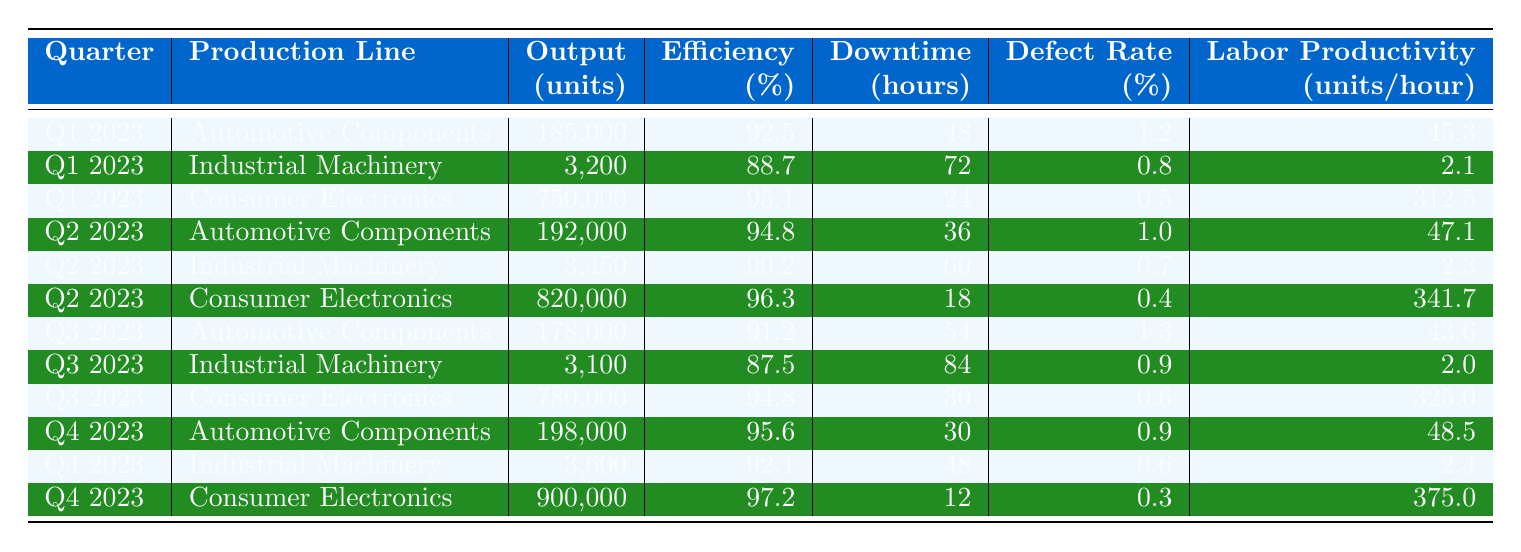What was the output of Consumer Electronics in Q4 2023? The output for Consumer Electronics in Q4 2023 is listed directly in the table as 900,000 units.
Answer: 900,000 What is the average efficiency for Automotive Components over the four quarters? The efficiencies for Automotive Components are 92.5, 94.8, 91.2, and 95.6. Adding these gives 374.1 and dividing by 4 yields 93.525.
Answer: 93.53 Was the defect rate for Industrial Machinery higher than for Consumer Electronics in Q1 2023? The defect rate for Industrial Machinery in Q1 2023 is 0.8%, and for Consumer Electronics, it is 0.5%. Since 0.8% is greater than 0.5%, the statement is true.
Answer: Yes Which production line had the highest labor productivity in Q2 2023? The labor productivity values for Q2 2023 are 47.1 for Automotive Components, 2.3 for Industrial Machinery, and 341.7 for Consumer Electronics. The highest value is 341.7, associated with Consumer Electronics.
Answer: Consumer Electronics What is the total output for Automotive Components across all quarters? The outputs for Automotive Components are 185,000 (Q1), 192,000 (Q2), 178,000 (Q3), and 198,000 (Q4). Adding these values gives a total output of 753,000 units.
Answer: 753,000 In which quarter did Industrial Machinery have the least downtime? The downtime for Industrial Machinery is recorded as 72 (Q1), 60 (Q2), 84 (Q3), and 48 (Q4). The least downtime is 48 hours in Q4.
Answer: Q4 2023 What percentage of efficiency was achieved by Consumer Electronics in Q3 2023? The efficiency for Consumer Electronics in Q3 2023 is explicitly indicated in the table as 94.8%.
Answer: 94.8% What is the difference in defect rates between Automotive Components and Consumer Electronics in Q2 2023? The defect rate for Automotive Components in Q2 2023 is 1.0%, and for Consumer Electronics, it is 0.4%. The difference is calculated as 1.0 - 0.4, which equals 0.6%.
Answer: 0.6% Which production line consistently maintained an efficiency above 90% throughout the four quarters? By reviewing the efficiency values for each quarter, Automotive Components (92.5, 94.8, 91.2, 95.6) consistently maintained an efficiency above 90%.
Answer: Automotive Components What was the total downtime across all quarters for Consumer Electronics? The downtimes for Consumer Electronics are 24 (Q1), 18 (Q2), 30 (Q3), and 12 (Q4). Adding these gives a total downtime of 84 hours across all quarters.
Answer: 84 Which production line had the highest output in Q3 2023? In Q3 2023, the outputs were 178,000 for Automotive Components, 3,100 for Industrial Machinery, and 780,000 for Consumer Electronics. The highest output is 780,000 units from Consumer Electronics.
Answer: Consumer Electronics 